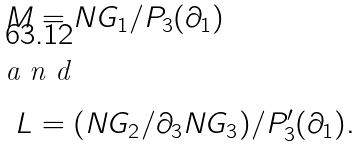Convert formula to latex. <formula><loc_0><loc_0><loc_500><loc_500>M & = N G _ { 1 } / P _ { 3 } ( \partial _ { 1 } ) \\ \intertext { a n d } L & = ( N G _ { 2 } / \partial _ { 3 } N G _ { 3 } ) / P _ { 3 } ^ { \prime } ( \partial _ { 1 } ) .</formula> 